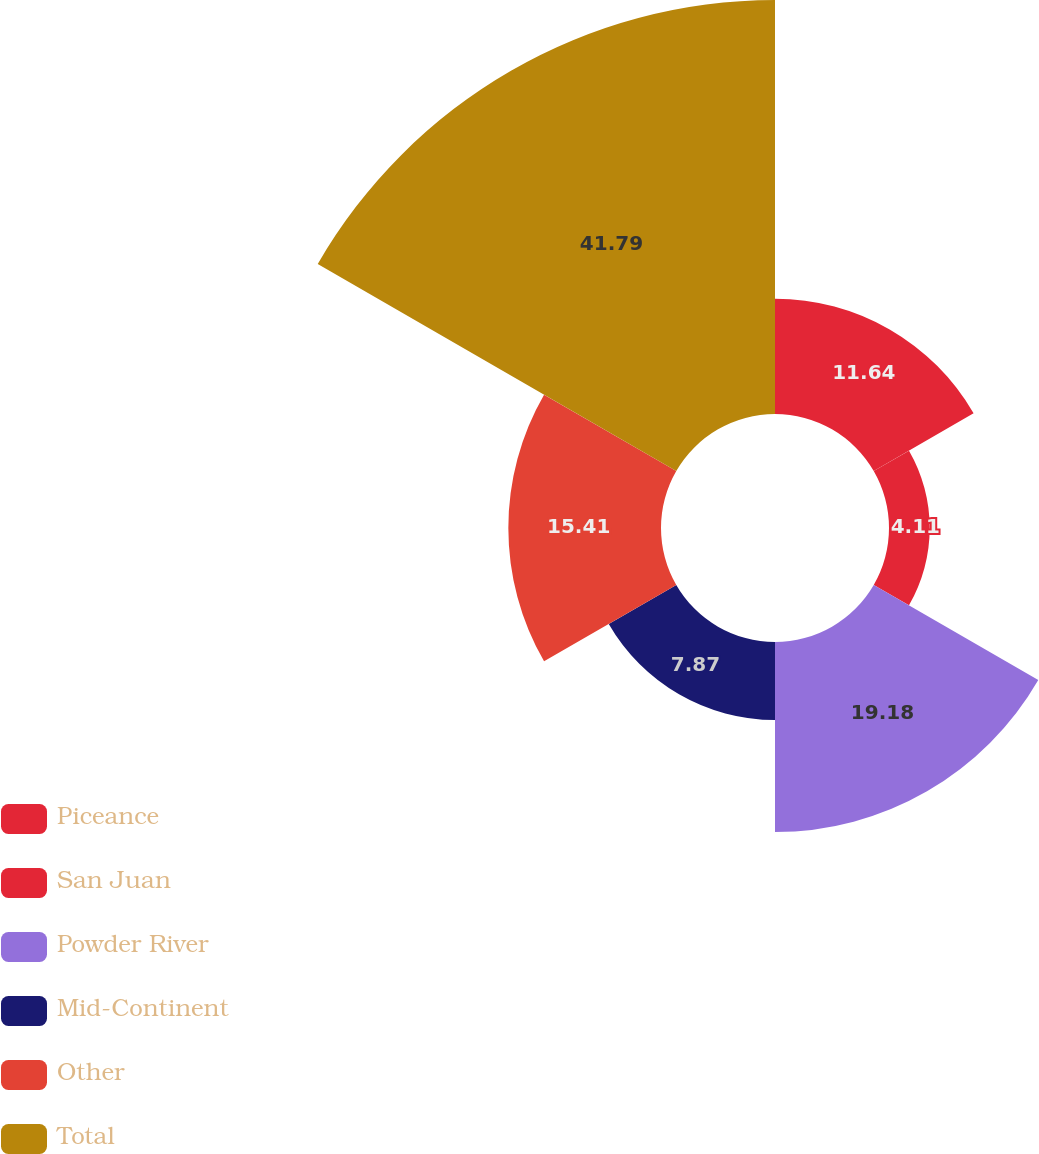Convert chart. <chart><loc_0><loc_0><loc_500><loc_500><pie_chart><fcel>Piceance<fcel>San Juan<fcel>Powder River<fcel>Mid-Continent<fcel>Other<fcel>Total<nl><fcel>11.64%<fcel>4.11%<fcel>19.18%<fcel>7.87%<fcel>15.41%<fcel>41.79%<nl></chart> 